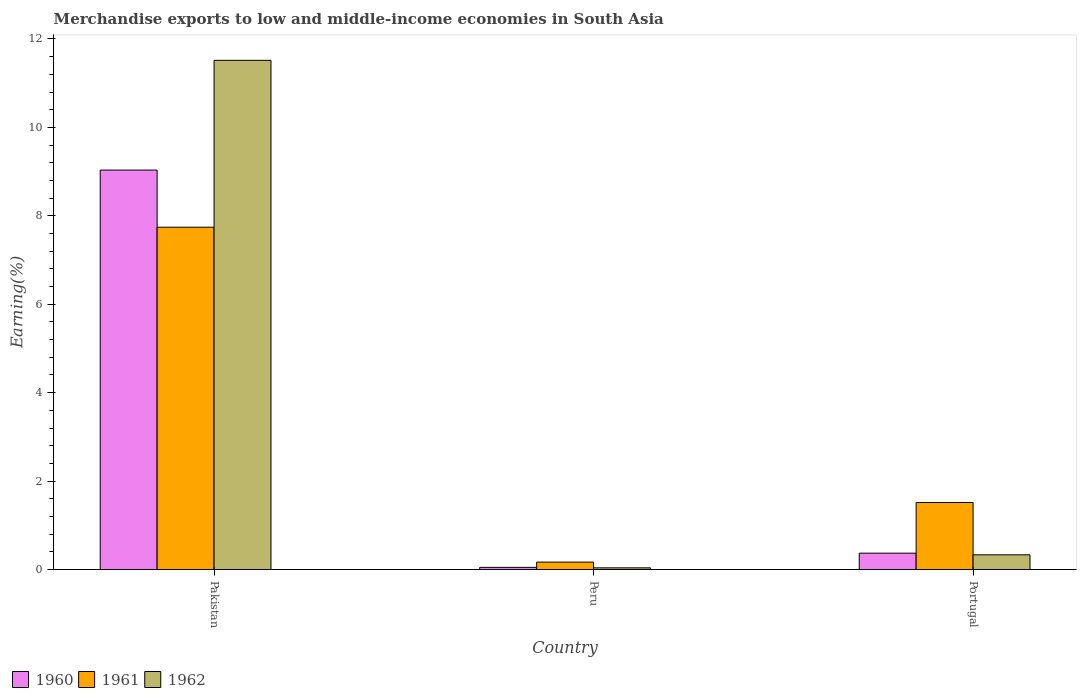Are the number of bars on each tick of the X-axis equal?
Give a very brief answer. Yes. In how many cases, is the number of bars for a given country not equal to the number of legend labels?
Keep it short and to the point. 0. What is the percentage of amount earned from merchandise exports in 1961 in Portugal?
Provide a short and direct response. 1.52. Across all countries, what is the maximum percentage of amount earned from merchandise exports in 1962?
Make the answer very short. 11.52. Across all countries, what is the minimum percentage of amount earned from merchandise exports in 1961?
Your response must be concise. 0.17. In which country was the percentage of amount earned from merchandise exports in 1960 minimum?
Ensure brevity in your answer.  Peru. What is the total percentage of amount earned from merchandise exports in 1960 in the graph?
Offer a very short reply. 9.45. What is the difference between the percentage of amount earned from merchandise exports in 1960 in Pakistan and that in Portugal?
Give a very brief answer. 8.67. What is the difference between the percentage of amount earned from merchandise exports in 1961 in Portugal and the percentage of amount earned from merchandise exports in 1962 in Pakistan?
Make the answer very short. -10. What is the average percentage of amount earned from merchandise exports in 1962 per country?
Your answer should be compact. 3.96. What is the difference between the percentage of amount earned from merchandise exports of/in 1962 and percentage of amount earned from merchandise exports of/in 1960 in Peru?
Your response must be concise. -0.01. What is the ratio of the percentage of amount earned from merchandise exports in 1960 in Peru to that in Portugal?
Offer a very short reply. 0.13. Is the percentage of amount earned from merchandise exports in 1962 in Pakistan less than that in Peru?
Keep it short and to the point. No. Is the difference between the percentage of amount earned from merchandise exports in 1962 in Pakistan and Peru greater than the difference between the percentage of amount earned from merchandise exports in 1960 in Pakistan and Peru?
Ensure brevity in your answer.  Yes. What is the difference between the highest and the second highest percentage of amount earned from merchandise exports in 1960?
Your answer should be very brief. -8.67. What is the difference between the highest and the lowest percentage of amount earned from merchandise exports in 1960?
Provide a succinct answer. 8.99. In how many countries, is the percentage of amount earned from merchandise exports in 1961 greater than the average percentage of amount earned from merchandise exports in 1961 taken over all countries?
Offer a terse response. 1. What does the 3rd bar from the right in Portugal represents?
Provide a succinct answer. 1960. How many bars are there?
Provide a short and direct response. 9. Are the values on the major ticks of Y-axis written in scientific E-notation?
Make the answer very short. No. Does the graph contain grids?
Offer a terse response. No. Where does the legend appear in the graph?
Your response must be concise. Bottom left. What is the title of the graph?
Make the answer very short. Merchandise exports to low and middle-income economies in South Asia. Does "1976" appear as one of the legend labels in the graph?
Offer a very short reply. No. What is the label or title of the Y-axis?
Your answer should be very brief. Earning(%). What is the Earning(%) in 1960 in Pakistan?
Your response must be concise. 9.04. What is the Earning(%) in 1961 in Pakistan?
Your answer should be compact. 7.74. What is the Earning(%) in 1962 in Pakistan?
Make the answer very short. 11.52. What is the Earning(%) of 1960 in Peru?
Provide a succinct answer. 0.05. What is the Earning(%) in 1961 in Peru?
Your answer should be very brief. 0.17. What is the Earning(%) of 1962 in Peru?
Offer a terse response. 0.04. What is the Earning(%) of 1960 in Portugal?
Provide a short and direct response. 0.37. What is the Earning(%) in 1961 in Portugal?
Your answer should be compact. 1.52. What is the Earning(%) of 1962 in Portugal?
Offer a terse response. 0.33. Across all countries, what is the maximum Earning(%) in 1960?
Your answer should be compact. 9.04. Across all countries, what is the maximum Earning(%) of 1961?
Your answer should be compact. 7.74. Across all countries, what is the maximum Earning(%) in 1962?
Your answer should be very brief. 11.52. Across all countries, what is the minimum Earning(%) in 1960?
Offer a terse response. 0.05. Across all countries, what is the minimum Earning(%) in 1961?
Your answer should be compact. 0.17. Across all countries, what is the minimum Earning(%) in 1962?
Provide a short and direct response. 0.04. What is the total Earning(%) in 1960 in the graph?
Provide a short and direct response. 9.45. What is the total Earning(%) of 1961 in the graph?
Provide a succinct answer. 9.43. What is the total Earning(%) in 1962 in the graph?
Give a very brief answer. 11.89. What is the difference between the Earning(%) of 1960 in Pakistan and that in Peru?
Your response must be concise. 8.99. What is the difference between the Earning(%) of 1961 in Pakistan and that in Peru?
Offer a terse response. 7.58. What is the difference between the Earning(%) of 1962 in Pakistan and that in Peru?
Your response must be concise. 11.48. What is the difference between the Earning(%) in 1960 in Pakistan and that in Portugal?
Your answer should be compact. 8.67. What is the difference between the Earning(%) in 1961 in Pakistan and that in Portugal?
Make the answer very short. 6.23. What is the difference between the Earning(%) of 1962 in Pakistan and that in Portugal?
Provide a succinct answer. 11.18. What is the difference between the Earning(%) in 1960 in Peru and that in Portugal?
Provide a short and direct response. -0.32. What is the difference between the Earning(%) of 1961 in Peru and that in Portugal?
Your response must be concise. -1.35. What is the difference between the Earning(%) of 1962 in Peru and that in Portugal?
Provide a succinct answer. -0.29. What is the difference between the Earning(%) of 1960 in Pakistan and the Earning(%) of 1961 in Peru?
Keep it short and to the point. 8.87. What is the difference between the Earning(%) of 1960 in Pakistan and the Earning(%) of 1962 in Peru?
Ensure brevity in your answer.  9. What is the difference between the Earning(%) in 1961 in Pakistan and the Earning(%) in 1962 in Peru?
Keep it short and to the point. 7.71. What is the difference between the Earning(%) in 1960 in Pakistan and the Earning(%) in 1961 in Portugal?
Ensure brevity in your answer.  7.52. What is the difference between the Earning(%) of 1960 in Pakistan and the Earning(%) of 1962 in Portugal?
Provide a short and direct response. 8.7. What is the difference between the Earning(%) in 1961 in Pakistan and the Earning(%) in 1962 in Portugal?
Keep it short and to the point. 7.41. What is the difference between the Earning(%) of 1960 in Peru and the Earning(%) of 1961 in Portugal?
Provide a short and direct response. -1.47. What is the difference between the Earning(%) in 1960 in Peru and the Earning(%) in 1962 in Portugal?
Give a very brief answer. -0.28. What is the difference between the Earning(%) of 1961 in Peru and the Earning(%) of 1962 in Portugal?
Ensure brevity in your answer.  -0.16. What is the average Earning(%) in 1960 per country?
Offer a terse response. 3.15. What is the average Earning(%) of 1961 per country?
Offer a terse response. 3.14. What is the average Earning(%) in 1962 per country?
Make the answer very short. 3.96. What is the difference between the Earning(%) in 1960 and Earning(%) in 1961 in Pakistan?
Your response must be concise. 1.29. What is the difference between the Earning(%) of 1960 and Earning(%) of 1962 in Pakistan?
Make the answer very short. -2.48. What is the difference between the Earning(%) in 1961 and Earning(%) in 1962 in Pakistan?
Give a very brief answer. -3.77. What is the difference between the Earning(%) in 1960 and Earning(%) in 1961 in Peru?
Your response must be concise. -0.12. What is the difference between the Earning(%) of 1960 and Earning(%) of 1962 in Peru?
Provide a succinct answer. 0.01. What is the difference between the Earning(%) of 1961 and Earning(%) of 1962 in Peru?
Your answer should be compact. 0.13. What is the difference between the Earning(%) of 1960 and Earning(%) of 1961 in Portugal?
Offer a terse response. -1.15. What is the difference between the Earning(%) of 1960 and Earning(%) of 1962 in Portugal?
Provide a short and direct response. 0.04. What is the difference between the Earning(%) in 1961 and Earning(%) in 1962 in Portugal?
Offer a terse response. 1.18. What is the ratio of the Earning(%) in 1960 in Pakistan to that in Peru?
Make the answer very short. 184.68. What is the ratio of the Earning(%) of 1961 in Pakistan to that in Peru?
Give a very brief answer. 46.1. What is the ratio of the Earning(%) in 1962 in Pakistan to that in Peru?
Offer a terse response. 302.79. What is the ratio of the Earning(%) of 1960 in Pakistan to that in Portugal?
Ensure brevity in your answer.  24.41. What is the ratio of the Earning(%) in 1961 in Pakistan to that in Portugal?
Make the answer very short. 5.11. What is the ratio of the Earning(%) in 1962 in Pakistan to that in Portugal?
Your response must be concise. 34.62. What is the ratio of the Earning(%) in 1960 in Peru to that in Portugal?
Give a very brief answer. 0.13. What is the ratio of the Earning(%) in 1961 in Peru to that in Portugal?
Make the answer very short. 0.11. What is the ratio of the Earning(%) of 1962 in Peru to that in Portugal?
Your answer should be compact. 0.11. What is the difference between the highest and the second highest Earning(%) in 1960?
Your response must be concise. 8.67. What is the difference between the highest and the second highest Earning(%) of 1961?
Make the answer very short. 6.23. What is the difference between the highest and the second highest Earning(%) in 1962?
Ensure brevity in your answer.  11.18. What is the difference between the highest and the lowest Earning(%) in 1960?
Ensure brevity in your answer.  8.99. What is the difference between the highest and the lowest Earning(%) of 1961?
Offer a very short reply. 7.58. What is the difference between the highest and the lowest Earning(%) of 1962?
Give a very brief answer. 11.48. 